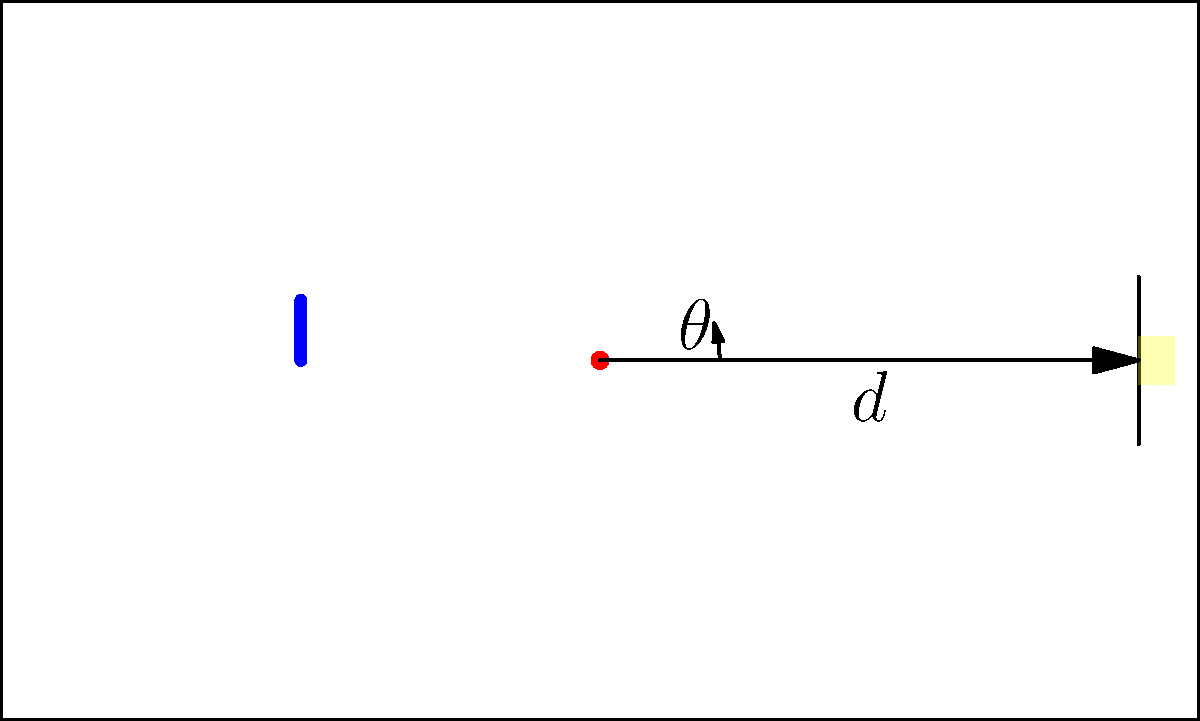In a crucial free kick situation, you're positioned at the center of the field. The defensive wall is 25 meters away, and the goal is 45 meters from your position. If the optimal target area is 2 meters wide at the center of the goal, what should be the approximate angle $\theta$ (in degrees) and the required ball curve radius $R$ (in meters) for a successful free kick? Let's approach this step-by-step:

1) First, we need to calculate the angle $\theta$:
   - The target width is 2 meters
   - The distance to the goal is 45 meters
   - Using the small angle approximation: $\theta \approx \frac{\text{arc length}}{\text{radius}} = \frac{2}{45} \approx 0.0444$ radians

2) Convert radians to degrees:
   $\theta \approx 0.0444 \times \frac{180}{\pi} \approx 2.54°$

3) Now, for the curve radius $R$:
   - We can use the equation for a circular arc: $s = R\theta$
   - Where $s$ is the arc length (distance to goal) and $\theta$ is in radians
   - $45 = R \times 0.0444$
   - $R = \frac{45}{0.0444} \approx 1013.5$ meters

4) However, this is an idealized scenario. In practice, due to air resistance and spin, the actual curve would be more complex. A more realistic curve radius for a free kick would be between 10-30 meters.

5) Let's adjust our angle to account for a more realistic curve:
   - Assuming a curve radius of 20 meters:
   - $45 = 20\theta$
   - $\theta = \frac{45}{20} = 2.25$ radians $\approx 129°$

Therefore, a more practical angle would be around 129°, with a curve radius of about 20 meters.
Answer: $\theta \approx 129°$, $R \approx 20$ m 